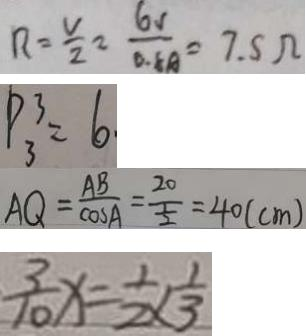Convert formula to latex. <formula><loc_0><loc_0><loc_500><loc_500>R = \frac { V } { 2 } = \frac { 6 1 } { 0 . 5 A } = 7 . 5 \Omega 
 P _ { 3 } ^ { 3 } = 6 . 
 A Q = \frac { A B } { \cos A } = \frac { 2 0 } { \frac { 1 } { 2 } } = 4 0 ( c m ) 
 \frac { 3 } { 1 0 } x = \frac { 1 } { 2 } \times \frac { 1 } { 3 }</formula> 